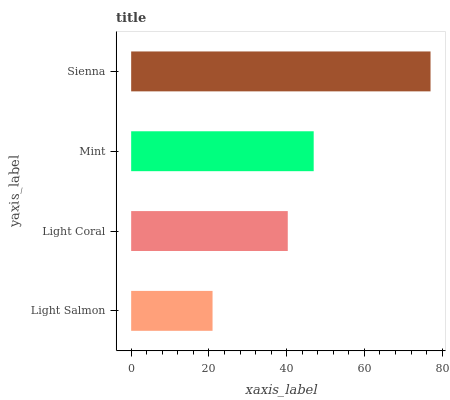Is Light Salmon the minimum?
Answer yes or no. Yes. Is Sienna the maximum?
Answer yes or no. Yes. Is Light Coral the minimum?
Answer yes or no. No. Is Light Coral the maximum?
Answer yes or no. No. Is Light Coral greater than Light Salmon?
Answer yes or no. Yes. Is Light Salmon less than Light Coral?
Answer yes or no. Yes. Is Light Salmon greater than Light Coral?
Answer yes or no. No. Is Light Coral less than Light Salmon?
Answer yes or no. No. Is Mint the high median?
Answer yes or no. Yes. Is Light Coral the low median?
Answer yes or no. Yes. Is Sienna the high median?
Answer yes or no. No. Is Mint the low median?
Answer yes or no. No. 